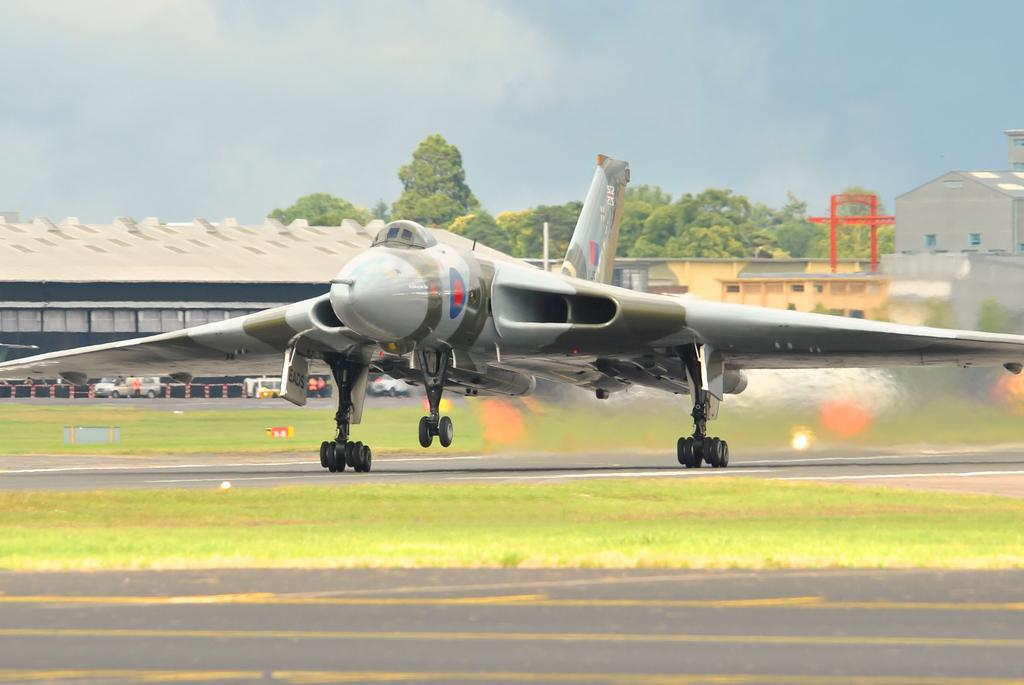What type of vehicle is on the runway in the image? There is a jet plane on the runway in the image. What structures can be seen in the image? There are buildings visible in the image. What type of vegetation is present in the image? There are trees in the image. What type of vehicles are present in the image besides the jet plane? There are cars in the image. What is the ground covered with in the image? The ground is covered with grass. How would you describe the sky in the image? The sky is blue and cloudy in the image. What type of plastic is used to make the order form for the tank in the image? There is no plastic, order form, or tank present in the image. 